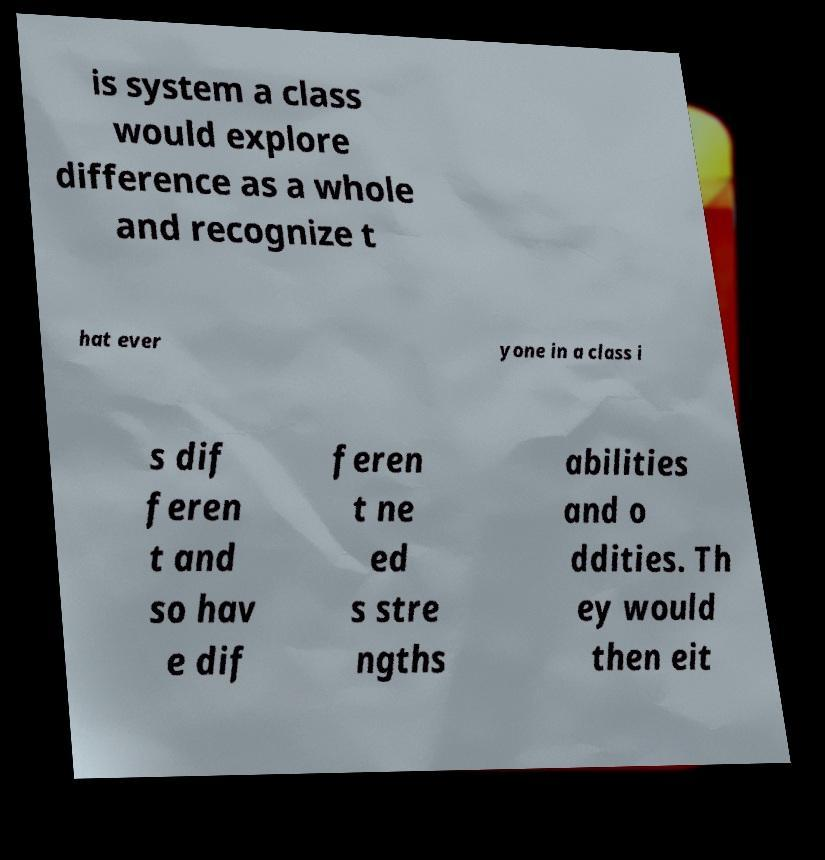Can you accurately transcribe the text from the provided image for me? is system a class would explore difference as a whole and recognize t hat ever yone in a class i s dif feren t and so hav e dif feren t ne ed s stre ngths abilities and o ddities. Th ey would then eit 